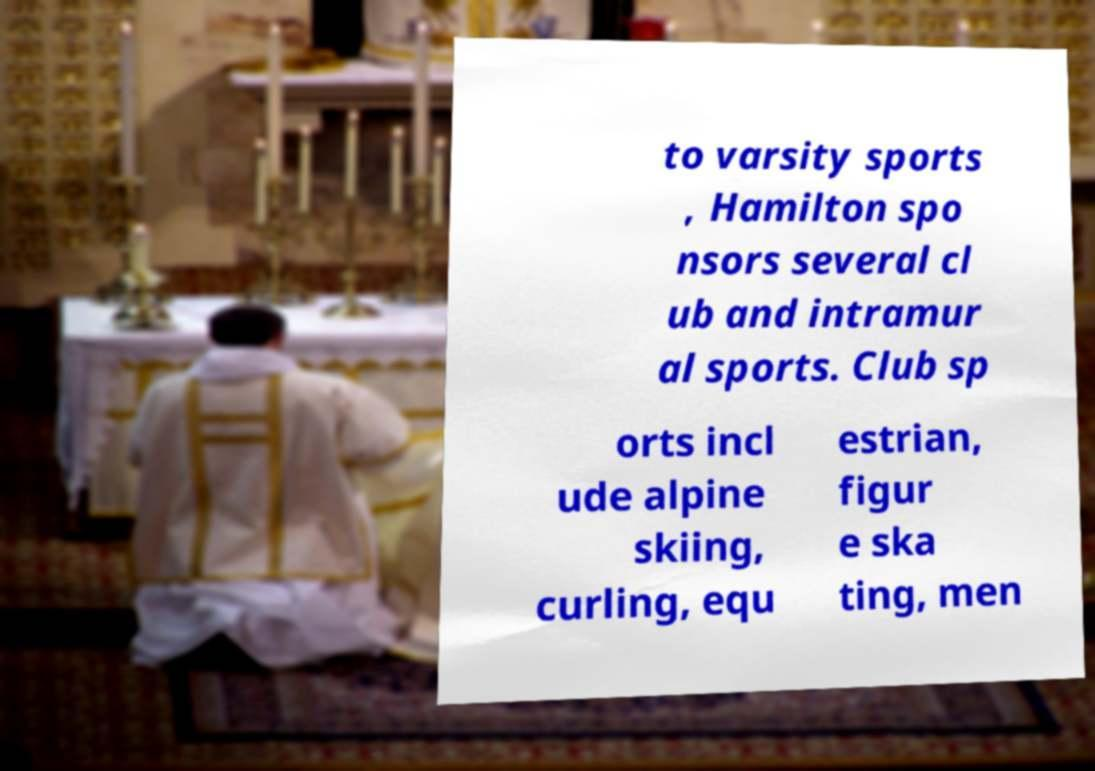What messages or text are displayed in this image? I need them in a readable, typed format. to varsity sports , Hamilton spo nsors several cl ub and intramur al sports. Club sp orts incl ude alpine skiing, curling, equ estrian, figur e ska ting, men 